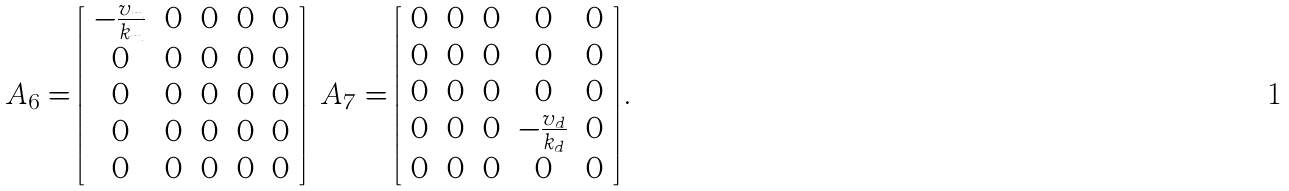<formula> <loc_0><loc_0><loc_500><loc_500>A _ { 6 } = \left [ \begin{array} { c c c c c } - \frac { v _ { m } } { k _ { m } } & 0 & 0 & 0 & 0 \\ 0 & 0 & 0 & 0 & 0 \\ 0 & 0 & 0 & 0 & 0 \\ 0 & 0 & 0 & 0 & 0 \\ 0 & 0 & 0 & 0 & 0 \end{array} \right ] \ A _ { 7 } = \left [ \begin{array} { c c c c c } 0 & 0 & 0 & 0 & 0 \\ 0 & 0 & 0 & 0 & 0 \\ 0 & 0 & 0 & 0 & 0 \\ 0 & 0 & 0 & - \frac { v _ { d } } { k _ { d } } & 0 \\ 0 & 0 & 0 & 0 & 0 \end{array} \right ] .</formula> 